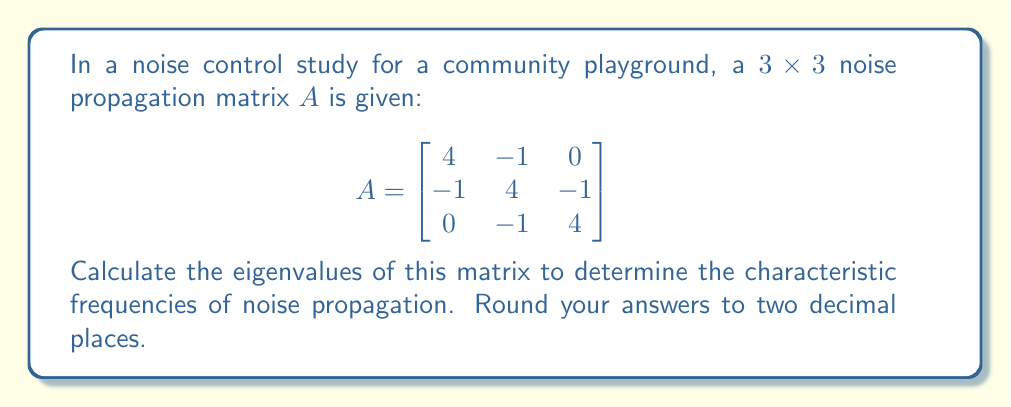Teach me how to tackle this problem. To find the eigenvalues of matrix $A$, we need to solve the characteristic equation:

1) First, we set up the equation $det(A - \lambda I) = 0$, where $I$ is the 3x3 identity matrix:

   $$det\begin{pmatrix}
   4-\lambda & -1 & 0 \\
   -1 & 4-\lambda & -1 \\
   0 & -1 & 4-\lambda
   \end{pmatrix} = 0$$

2) Expand the determinant:
   
   $(4-\lambda)[(4-\lambda)(4-\lambda) - 1] - (-1)[(-1)(4-\lambda) - 0] = 0$

3) Simplify:

   $(4-\lambda)[(4-\lambda)^2 - 1] + (4-\lambda) = 0$
   
   $(4-\lambda)[(4-\lambda)^2 - 1 + 1] = 0$
   
   $(4-\lambda)(4-\lambda)^2 = 0$

4) Factor the equation:

   $(4-\lambda)(\lambda^2 - 8\lambda + 16) = 0$
   
   $(4-\lambda)(\lambda - 4)^2 = 0$

5) Solve for $\lambda$:

   $\lambda_1 = 4$
   $\lambda_2 = \lambda_3 = 4$

Therefore, the eigenvalues are 4 (with algebraic multiplicity 3).
Answer: 4, 4, 4 